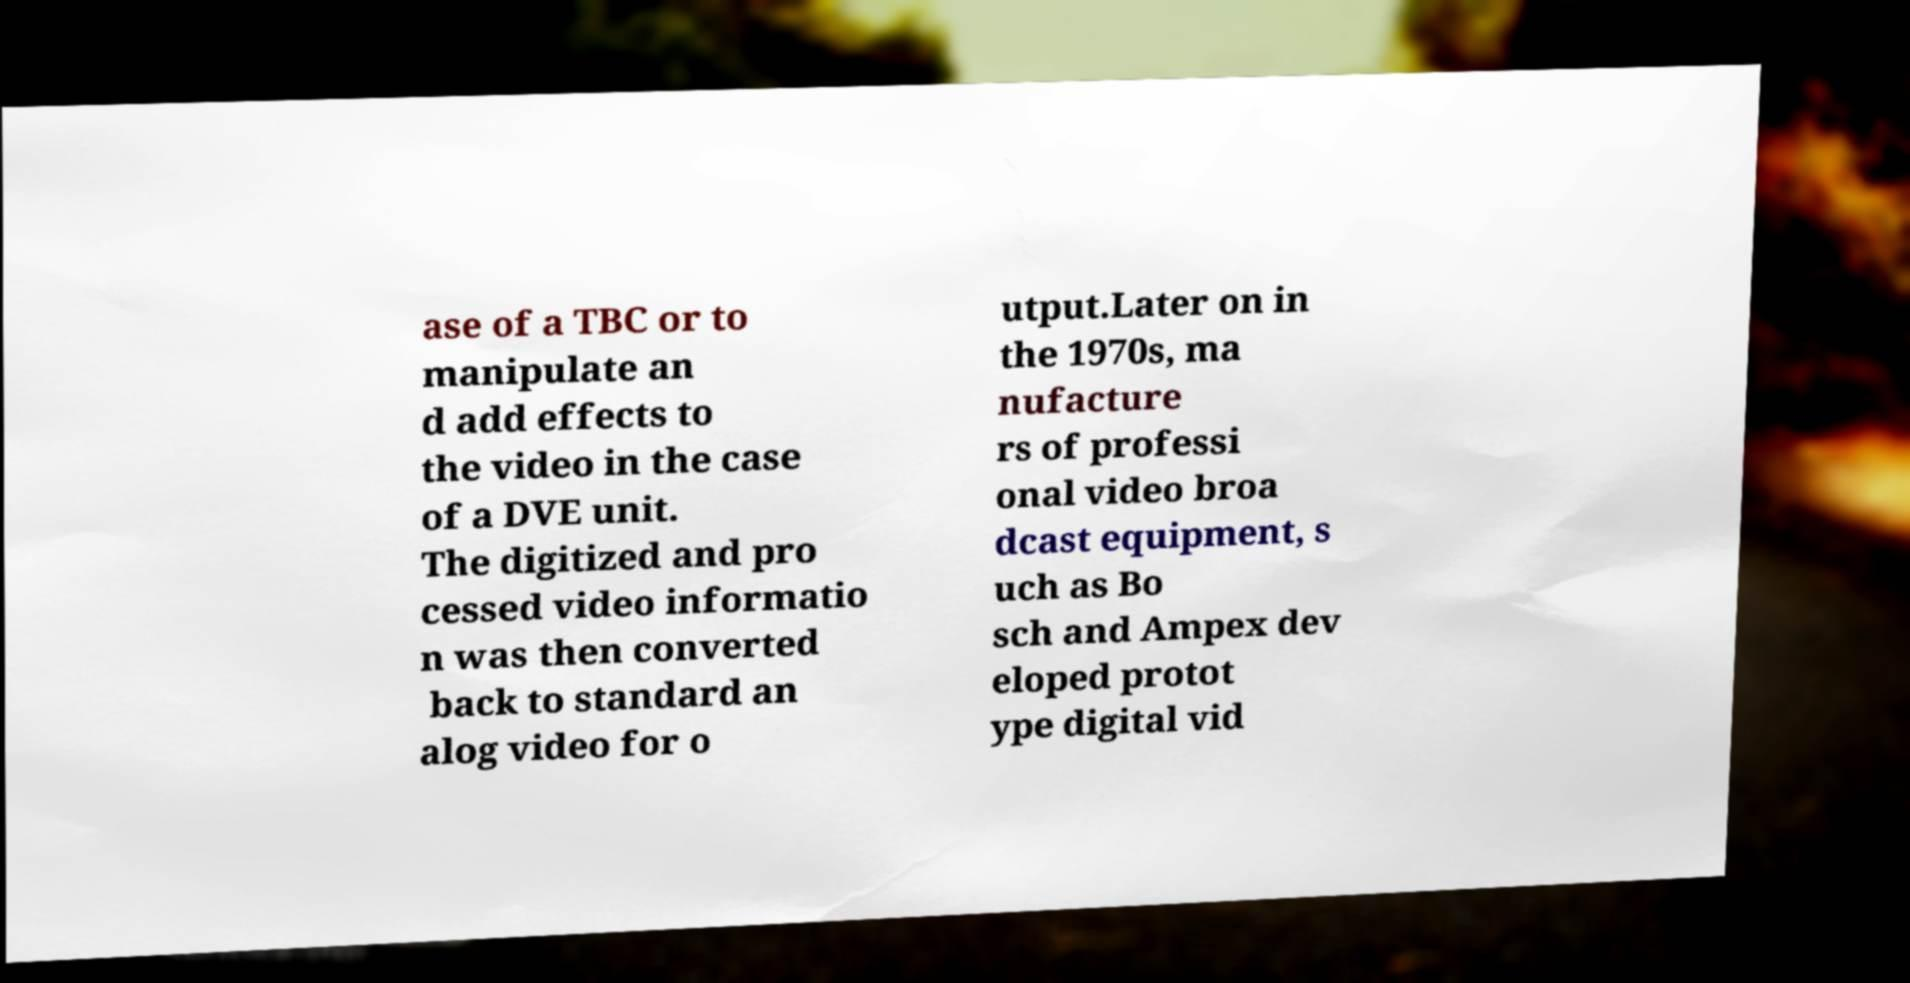What messages or text are displayed in this image? I need them in a readable, typed format. ase of a TBC or to manipulate an d add effects to the video in the case of a DVE unit. The digitized and pro cessed video informatio n was then converted back to standard an alog video for o utput.Later on in the 1970s, ma nufacture rs of professi onal video broa dcast equipment, s uch as Bo sch and Ampex dev eloped protot ype digital vid 